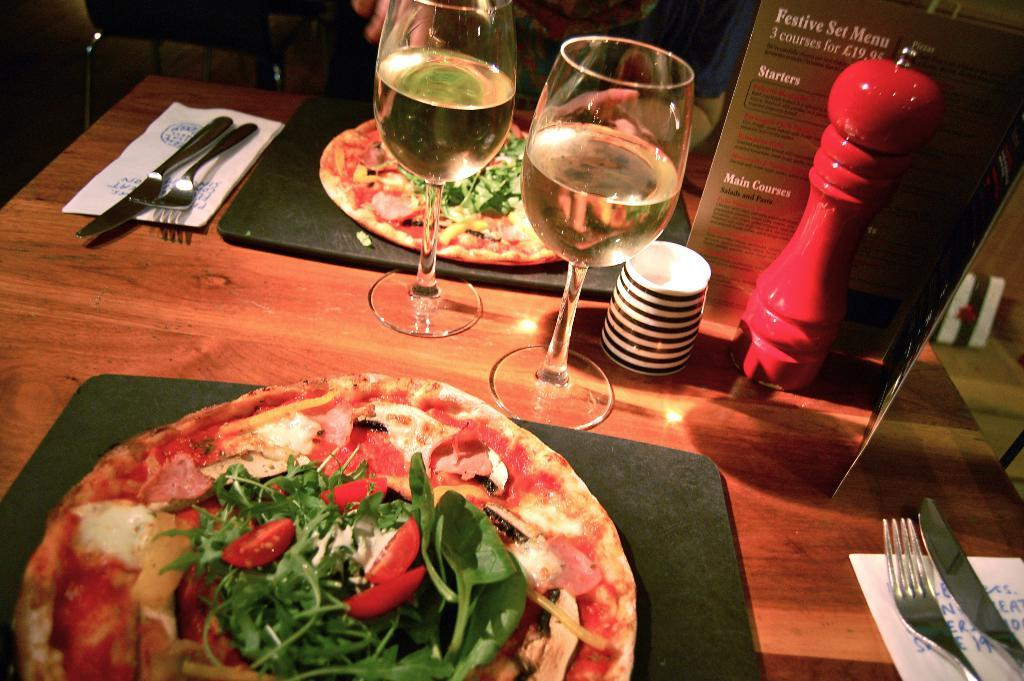What type of table is in the image? There is a wooden table in the image. What food items are on the table? There are two pizzas on the table. What else can be seen on the table besides the pizzas? There are two glasses and spoons on the table. Where are the bushes located in the image? There are no bushes present in the image. What color is the crayon on the table? There is no crayon present in the image. 